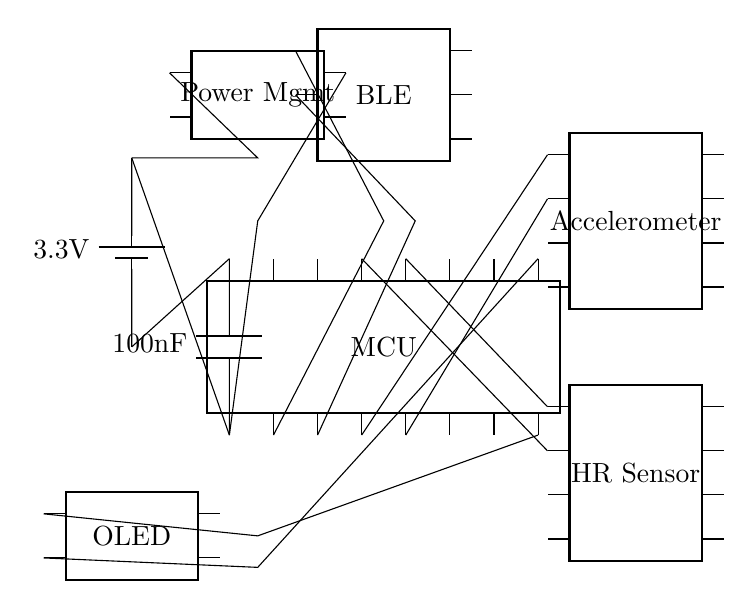What is the voltage supplied by the battery? The circuit shows a battery with a label indicating a supply voltage of 3.3V. The voltage is determined from the battery symbol in the circuit diagram.
Answer: 3.3 volts What components are connected to the microcontroller? The microcontroller has multiple connections. It is connected to an accelerometer, heart rate sensor, OLED display, Bluetooth module, and power management unit. Each component's connection is shown by lines extending from respective pins.
Answer: Accelerometer, heart rate sensor, OLED display, Bluetooth module, power management What is the function of the decoupling capacitor? The decoupling capacitor stabilizes the power supply by filtering out noise and providing a reservoir of charge to the microcontroller when there are rapid changes in current consumption. Its presence indicates that it's used for circuit stability, particularly for low-power applications.
Answer: Stabilize the power supply How many pins does the heart rate sensor have? The heart rate sensor in the circuit diagram is depicted as a dip chip with 8 pins. The visible structure and labeling of the component provide the necessary details about the number of pins.
Answer: 8 pins What is the role of the power management unit? The power management unit regulates the voltage and current supplied to the circuit components, ensuring that they receive the correct power levels for operations, essential in low power appliance designs to extend battery life. The connections to the microcontroller and battery denote its critical role in power regulation.
Answer: Power regulation In what way does the Bluetooth module connect to the circuit? The Bluetooth module connects to the microcontroller through its pins. Specifically, pins from the microcontroller connect to pins of the Bluetooth module, allowing for wireless communication functions. This connection highlights the module’s role in facilitating data transmission.
Answer: Through the microcontroller pins 